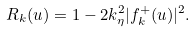<formula> <loc_0><loc_0><loc_500><loc_500>R _ { k } ( u ) = 1 - 2 k _ { \eta } ^ { 2 } | f ^ { + } _ { k } ( u ) | ^ { 2 } .</formula> 